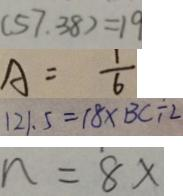Convert formula to latex. <formula><loc_0><loc_0><loc_500><loc_500>( 5 7 . 3 8 ) = 1 9 
 A = \frac { 1 } { 6 } 
 1 2 1 . 5 = 1 8 \times B C \div 2 
 n = 8 x</formula> 